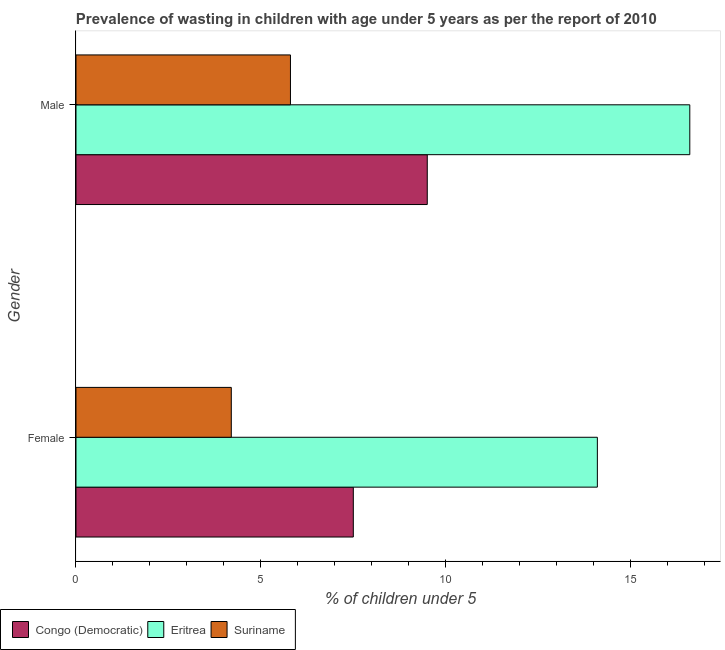How many groups of bars are there?
Your answer should be compact. 2. Are the number of bars per tick equal to the number of legend labels?
Give a very brief answer. Yes. Are the number of bars on each tick of the Y-axis equal?
Provide a short and direct response. Yes. How many bars are there on the 2nd tick from the top?
Your answer should be compact. 3. What is the percentage of undernourished female children in Suriname?
Ensure brevity in your answer.  4.2. Across all countries, what is the maximum percentage of undernourished female children?
Your answer should be compact. 14.1. Across all countries, what is the minimum percentage of undernourished female children?
Keep it short and to the point. 4.2. In which country was the percentage of undernourished male children maximum?
Keep it short and to the point. Eritrea. In which country was the percentage of undernourished male children minimum?
Your answer should be compact. Suriname. What is the total percentage of undernourished male children in the graph?
Keep it short and to the point. 31.9. What is the difference between the percentage of undernourished male children in Eritrea and that in Suriname?
Provide a short and direct response. 10.8. What is the difference between the percentage of undernourished male children in Congo (Democratic) and the percentage of undernourished female children in Suriname?
Offer a terse response. 5.3. What is the average percentage of undernourished female children per country?
Ensure brevity in your answer.  8.6. What is the ratio of the percentage of undernourished male children in Congo (Democratic) to that in Suriname?
Offer a terse response. 1.64. In how many countries, is the percentage of undernourished male children greater than the average percentage of undernourished male children taken over all countries?
Make the answer very short. 1. What does the 2nd bar from the top in Female represents?
Your response must be concise. Eritrea. What does the 3rd bar from the bottom in Male represents?
Provide a short and direct response. Suriname. Are all the bars in the graph horizontal?
Give a very brief answer. Yes. How many countries are there in the graph?
Ensure brevity in your answer.  3. What is the difference between two consecutive major ticks on the X-axis?
Provide a succinct answer. 5. Are the values on the major ticks of X-axis written in scientific E-notation?
Your answer should be compact. No. Does the graph contain any zero values?
Offer a very short reply. No. Does the graph contain grids?
Keep it short and to the point. No. Where does the legend appear in the graph?
Provide a short and direct response. Bottom left. How many legend labels are there?
Offer a very short reply. 3. What is the title of the graph?
Ensure brevity in your answer.  Prevalence of wasting in children with age under 5 years as per the report of 2010. What is the label or title of the X-axis?
Ensure brevity in your answer.   % of children under 5. What is the label or title of the Y-axis?
Provide a short and direct response. Gender. What is the  % of children under 5 of Eritrea in Female?
Keep it short and to the point. 14.1. What is the  % of children under 5 in Suriname in Female?
Keep it short and to the point. 4.2. What is the  % of children under 5 in Congo (Democratic) in Male?
Your answer should be compact. 9.5. What is the  % of children under 5 of Eritrea in Male?
Your answer should be very brief. 16.6. What is the  % of children under 5 in Suriname in Male?
Your response must be concise. 5.8. Across all Gender, what is the maximum  % of children under 5 in Eritrea?
Your answer should be very brief. 16.6. Across all Gender, what is the maximum  % of children under 5 of Suriname?
Offer a terse response. 5.8. Across all Gender, what is the minimum  % of children under 5 of Eritrea?
Your answer should be compact. 14.1. Across all Gender, what is the minimum  % of children under 5 of Suriname?
Keep it short and to the point. 4.2. What is the total  % of children under 5 in Eritrea in the graph?
Your answer should be compact. 30.7. What is the total  % of children under 5 of Suriname in the graph?
Offer a very short reply. 10. What is the difference between the  % of children under 5 in Congo (Democratic) in Female and that in Male?
Keep it short and to the point. -2. What is the difference between the  % of children under 5 of Eritrea in Female and that in Male?
Your answer should be very brief. -2.5. What is the difference between the  % of children under 5 of Congo (Democratic) in Female and the  % of children under 5 of Suriname in Male?
Your response must be concise. 1.7. What is the difference between the  % of children under 5 of Eritrea in Female and the  % of children under 5 of Suriname in Male?
Keep it short and to the point. 8.3. What is the average  % of children under 5 in Congo (Democratic) per Gender?
Provide a succinct answer. 8.5. What is the average  % of children under 5 in Eritrea per Gender?
Give a very brief answer. 15.35. What is the difference between the  % of children under 5 of Congo (Democratic) and  % of children under 5 of Eritrea in Female?
Provide a succinct answer. -6.6. What is the difference between the  % of children under 5 in Congo (Democratic) and  % of children under 5 in Suriname in Male?
Give a very brief answer. 3.7. What is the ratio of the  % of children under 5 in Congo (Democratic) in Female to that in Male?
Offer a very short reply. 0.79. What is the ratio of the  % of children under 5 of Eritrea in Female to that in Male?
Offer a very short reply. 0.85. What is the ratio of the  % of children under 5 in Suriname in Female to that in Male?
Your answer should be compact. 0.72. What is the difference between the highest and the second highest  % of children under 5 in Congo (Democratic)?
Your answer should be very brief. 2. What is the difference between the highest and the second highest  % of children under 5 in Eritrea?
Ensure brevity in your answer.  2.5. What is the difference between the highest and the lowest  % of children under 5 in Congo (Democratic)?
Offer a terse response. 2. What is the difference between the highest and the lowest  % of children under 5 of Eritrea?
Give a very brief answer. 2.5. What is the difference between the highest and the lowest  % of children under 5 of Suriname?
Your response must be concise. 1.6. 